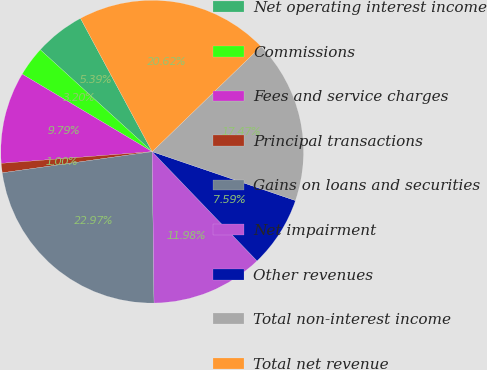Convert chart to OTSL. <chart><loc_0><loc_0><loc_500><loc_500><pie_chart><fcel>Net operating interest income<fcel>Commissions<fcel>Fees and service charges<fcel>Principal transactions<fcel>Gains on loans and securities<fcel>Net impairment<fcel>Other revenues<fcel>Total non-interest income<fcel>Total net revenue<nl><fcel>5.39%<fcel>3.2%<fcel>9.79%<fcel>1.0%<fcel>22.97%<fcel>11.98%<fcel>7.59%<fcel>17.47%<fcel>20.62%<nl></chart> 